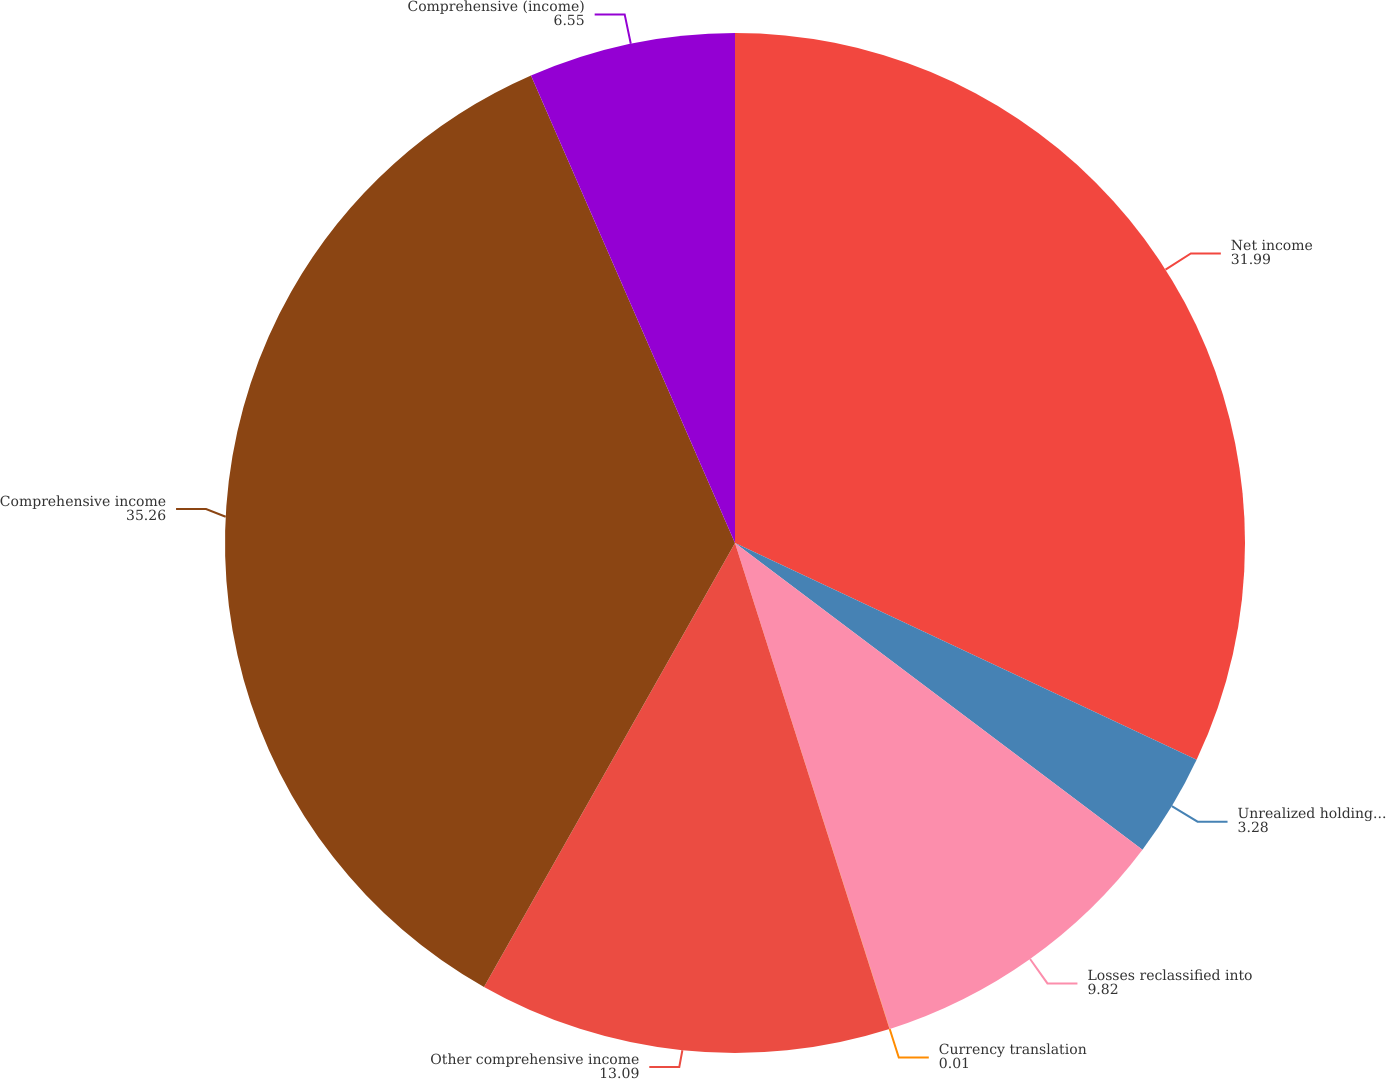Convert chart. <chart><loc_0><loc_0><loc_500><loc_500><pie_chart><fcel>Net income<fcel>Unrealized holding (losses)<fcel>Losses reclassified into<fcel>Currency translation<fcel>Other comprehensive income<fcel>Comprehensive income<fcel>Comprehensive (income)<nl><fcel>31.99%<fcel>3.28%<fcel>9.82%<fcel>0.01%<fcel>13.09%<fcel>35.26%<fcel>6.55%<nl></chart> 